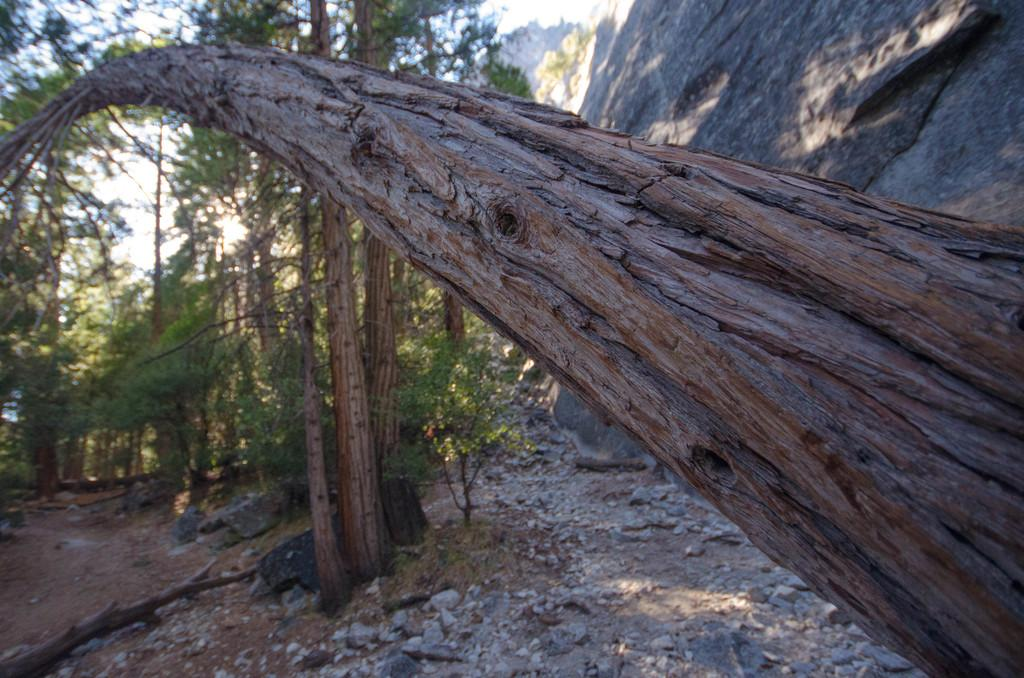What is the main subject in the foreground of the image? There is a tree trunk in the front of the image. What is located behind the tree trunk? There is a rock mountain behind the tree trunk. What can be seen beyond the rock mountain? There are trees visible behind the rock mountain. What type of stamp is visible on the tree trunk in the image? There is no stamp present on the tree trunk in the image. What kind of insurance policy is being advertised on the rock mountain in the image? There is no insurance policy or advertisement present on the rock mountain in the image. 